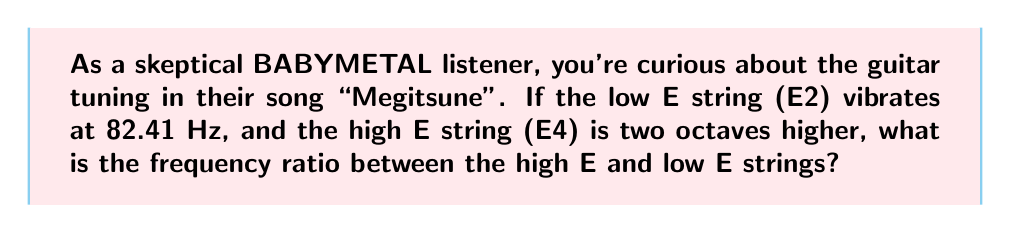Can you answer this question? Let's approach this step-by-step:

1) First, recall that an octave represents a doubling of frequency. So, for each octave increase, we multiply the frequency by 2.

2) The high E string (E4) is two octaves higher than the low E string (E2). This means we need to double the frequency twice:

   $$f_{E4} = f_{E2} \times 2 \times 2$$

3) We know that $f_{E2} = 82.41$ Hz. Let's substitute this:

   $$f_{E4} = 82.41 \times 2 \times 2 = 82.41 \times 4 = 329.64\text{ Hz}$$

4) Now, to find the frequency ratio, we divide the higher frequency by the lower frequency:

   $$\text{Ratio} = \frac{f_{E4}}{f_{E2}} = \frac{329.64}{82.41}$$

5) This simplifies to:

   $$\text{Ratio} = 4$$

This makes sense because we doubled the frequency twice, which is equivalent to multiplying by 4.
Answer: 4:1 